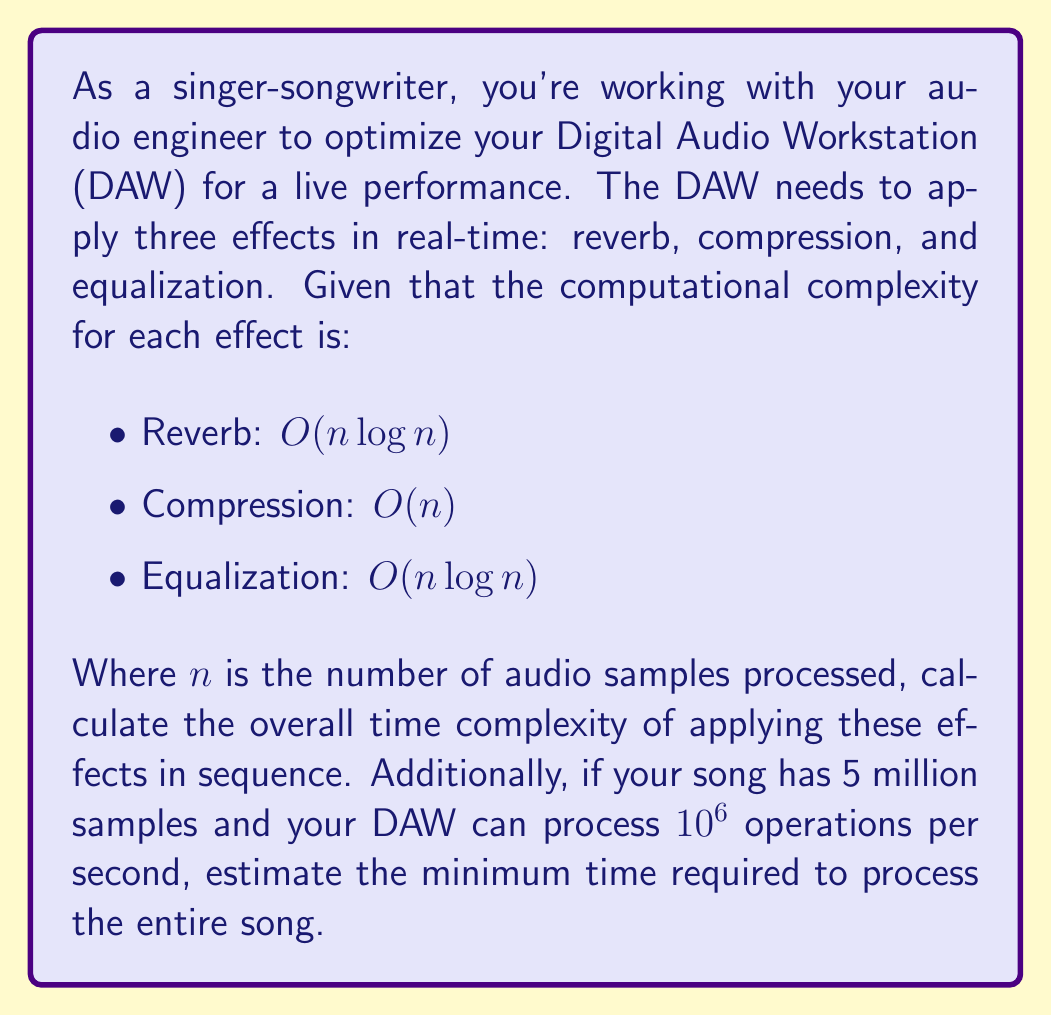Teach me how to tackle this problem. To solve this problem, we need to follow these steps:

1. Determine the overall time complexity:
   - When algorithms are applied in sequence, we add their complexities.
   - The overall complexity will be dominated by the highest order term.

   $$O(n \log n) + O(n) + O(n \log n) = O(n \log n + n + n \log n) = O(2n \log n + n)$$
   
   Simplifying, we get: $O(n \log n)$

2. Estimate the processing time:
   - We have $n = 5 \times 10^6$ samples
   - The DAW can process $10^6$ operations per second
   - The time complexity is $O(n \log n)$, so we need to calculate $n \log n$

   $$5 \times 10^6 \log(5 \times 10^6) \approx 5 \times 10^6 \times 6.7 \approx 3.35 \times 10^7$$

   - Dividing by the DAW's processing speed:
   
   $$\frac{3.35 \times 10^7}{10^6} = 33.5 \text{ seconds}$$

Note that this is a lower bound estimate, as the actual constant factors in the $O(n \log n)$ complexity are not considered, and there may be additional overhead in the DAW.
Answer: The overall time complexity is $O(n \log n)$, and the estimated minimum processing time is 33.5 seconds. 